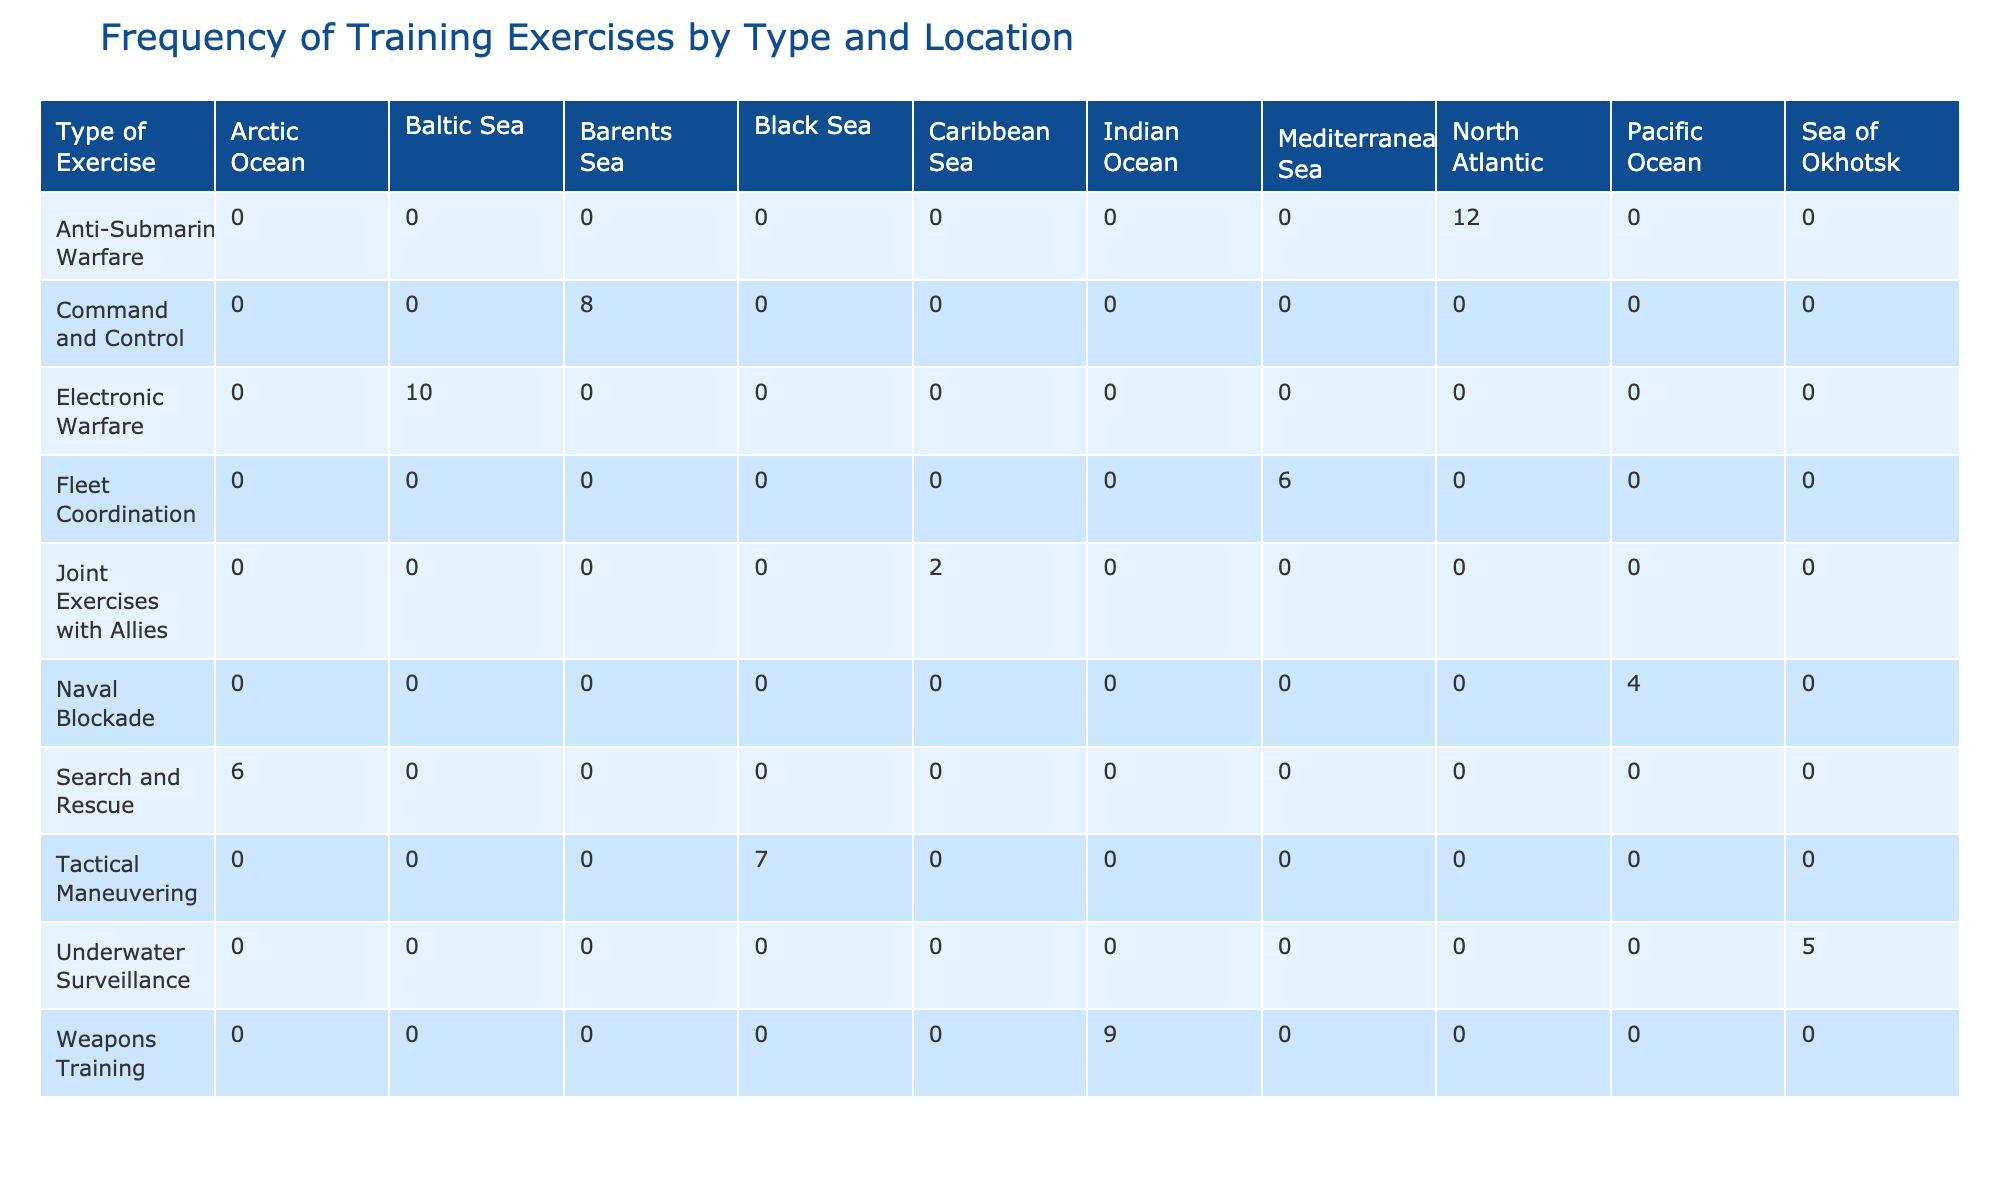What type of exercise has the highest frequency in the North Atlantic? According to the table, the "Anti-Submarine Warfare" exercise has a frequency of 12 per year, which is the highest among all listed exercises in the North Atlantic.
Answer: Anti-Submarine Warfare How many types of exercises are conducted in the Arctic Ocean? In the table, the Arctic Ocean has only one type of exercise listed, which is "Search and Rescue," with a frequency of 6 per year.
Answer: 1 What is the total frequency of training exercises conducted in the Baltic Sea? The "Electronic Warfare" exercise is the only type listed for the Baltic Sea with a frequency of 10 per year. Therefore, the total frequency is simply 10.
Answer: 10 Is there any exercise with a frequency of 2 in the Caribbean Sea? Yes, according to the table, "Joint Exercises with Allies" is listed under the Caribbean Sea with a frequency of 2 per year.
Answer: Yes Which geographical location has the lowest frequency of training exercises, and what is that frequency? From the table, the "Naval Blockade" in the Pacific Ocean has the lowest frequency at 4 per year, followed closely by "Underwater Surveillance" in the Sea of Okhotsk at 5 per year.
Answer: Pacific Ocean, 4 What is the average frequency of training exercises across all geographical locations? To find the average, first sum all the frequencies: 12 + 8 + 10 + 7 + 5 + 4 + 6 + 9 + 6 + 2 = 69. There are 10 exercises, so the average is 69 divided by 10, which equals 6.9.
Answer: 6.9 How many more frequencies does "Underwater Surveillance" have compared to "Joint Exercises with Allies"? "Underwater Surveillance" has a frequency of 5 per year, and "Joint Exercises with Allies" has a frequency of 2 per year. The difference is 5 - 2 = 3.
Answer: 3 What is the combined frequency of "Tactical Maneuvering" and "Fleet Coordination"? "Tactical Maneuvering" has a frequency of 7 per year and "Fleet Coordination" has a frequency of 6 per year. The combined frequency is 7 + 6 = 13.
Answer: 13 Are there any exercises conducted more than 10 times per year? Yes, "Anti-Submarine Warfare" is conducted 12 times per year, which exceeds 10.
Answer: Yes 